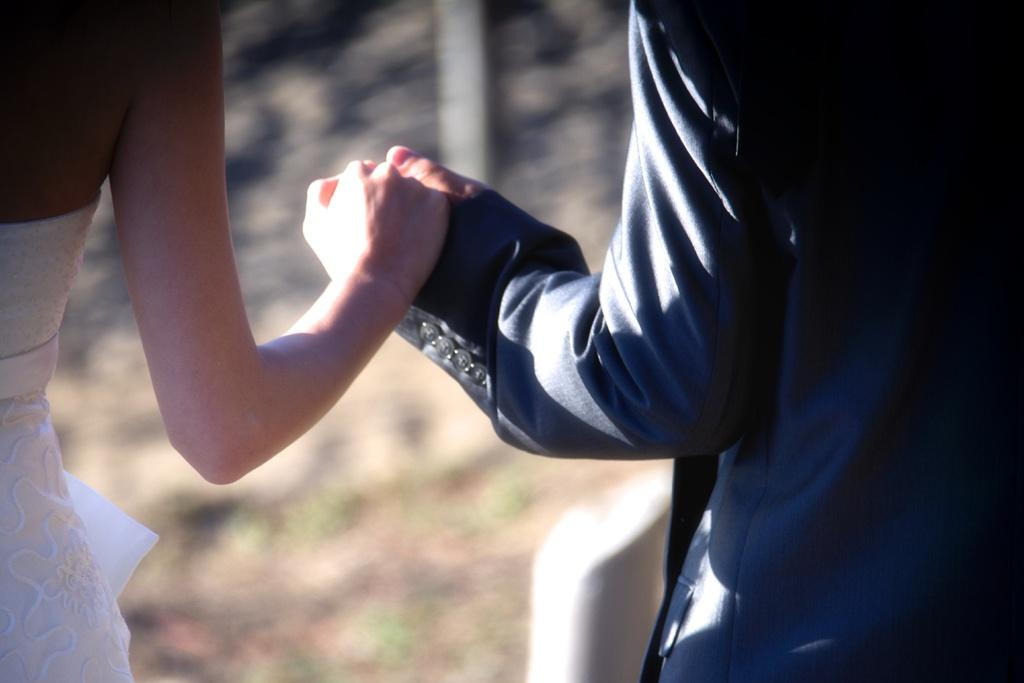How many people are in the image? There are people in the image, but the exact number is not specified. What are the people doing in the image? The people are holding their hands in the image. What type of rod can be seen growing in the plantation in the image? There is no rod or plantation present in the image; it only features people holding their hands. 